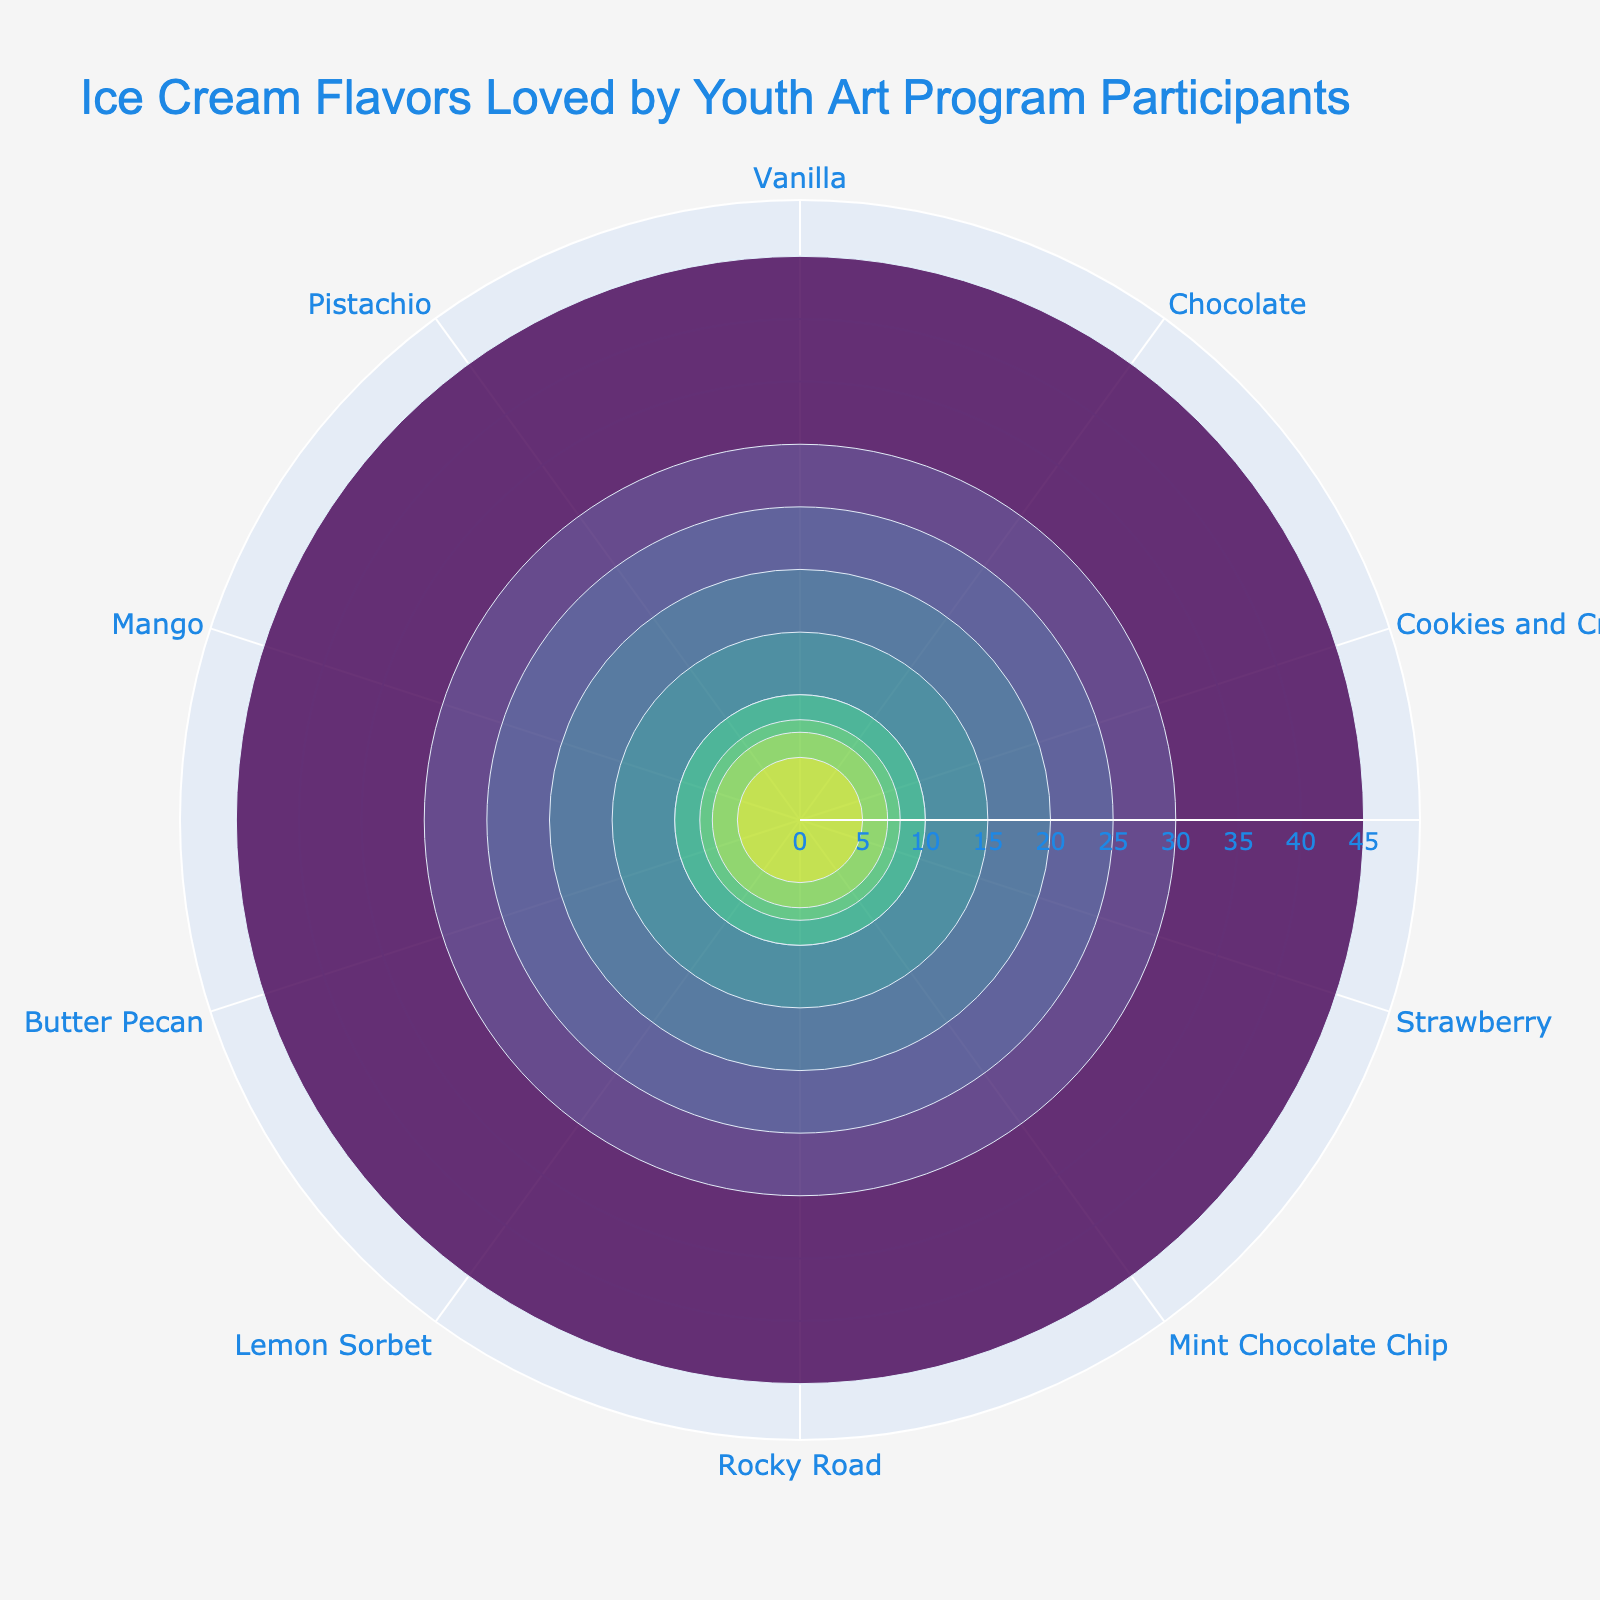what is the title of the figure? The title is shown at the top of the polar area chart in a large font. It states "Ice Cream Flavors Loved by Youth Art Program Participants".
Answer: Ice Cream Flavors Loved by Youth Art Program Participants How many ice cream flavors are displayed in the figure? You can count the number of distinct segments or wedges in the figure to determine the number of ice cream flavors.
Answer: 10 Which ice cream flavor has the highest number of participants? By examining the polar area chart, the flavor with the largest radial distance signifies the highest number of participants, which is Vanilla.
Answer: Vanilla Which two ice cream flavors are equally liked by participants? Look for the segments that have the same radial distance; Rocky Road and Lemon Sorbet both have a similar length in the chart.
Answer: Rocky Road and Lemon Sorbet What's the difference in participants between Vanilla and Chocolate? Look at the radial length for each flavor; Vanilla has 45 participants and Chocolate has 30. The difference is 45 - 30.
Answer: 15 How many participants like Pistachio and Lemon Sorbet combined? Find the participants for both flavors and add them; Pistachio has 5 and Lemon Sorbet has 10, so 5 + 10.
Answer: 15 Which flavor has the smallest number of participants and how many? Identify the segment with the smallest radial length which is Pistachio. It has the fewest participants.
Answer: Pistachio; 5 Are there more participants who like Mango or Butter Pecan? Compare the radial lengths of the segments for Mango and Butter Pecan; Butter Pecan has more participants.
Answer: Butter Pecan What's the average number of participants for Chocolate, Strawberry, and Mint Chocolate Chip flavors? Sum the participants for Chocolate (30), Strawberry (20), and Mint Chocolate Chip (15) and divide by 3: (30 + 20 + 15) / 3 = 21.67.
Answer: 21.67 Which flavor is in the middle when flavors are ordered by the number of participants? When ordered from highest to lowest number of participants, Cookies and Cream (25) are in the middle.
Answer: Cookies and Cream 